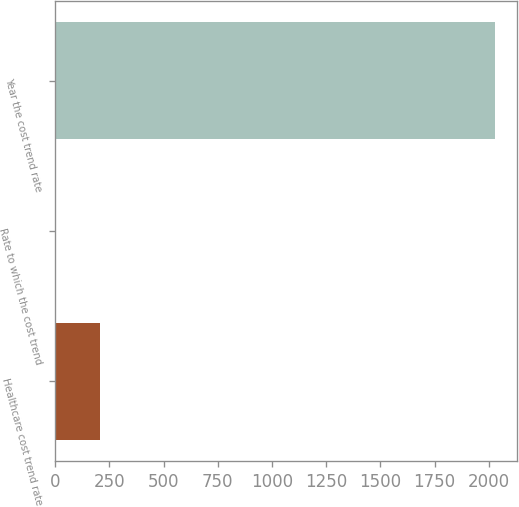Convert chart. <chart><loc_0><loc_0><loc_500><loc_500><bar_chart><fcel>Healthcare cost trend rate<fcel>Rate to which the cost trend<fcel>Year the cost trend rate<nl><fcel>206.75<fcel>4.5<fcel>2027<nl></chart> 